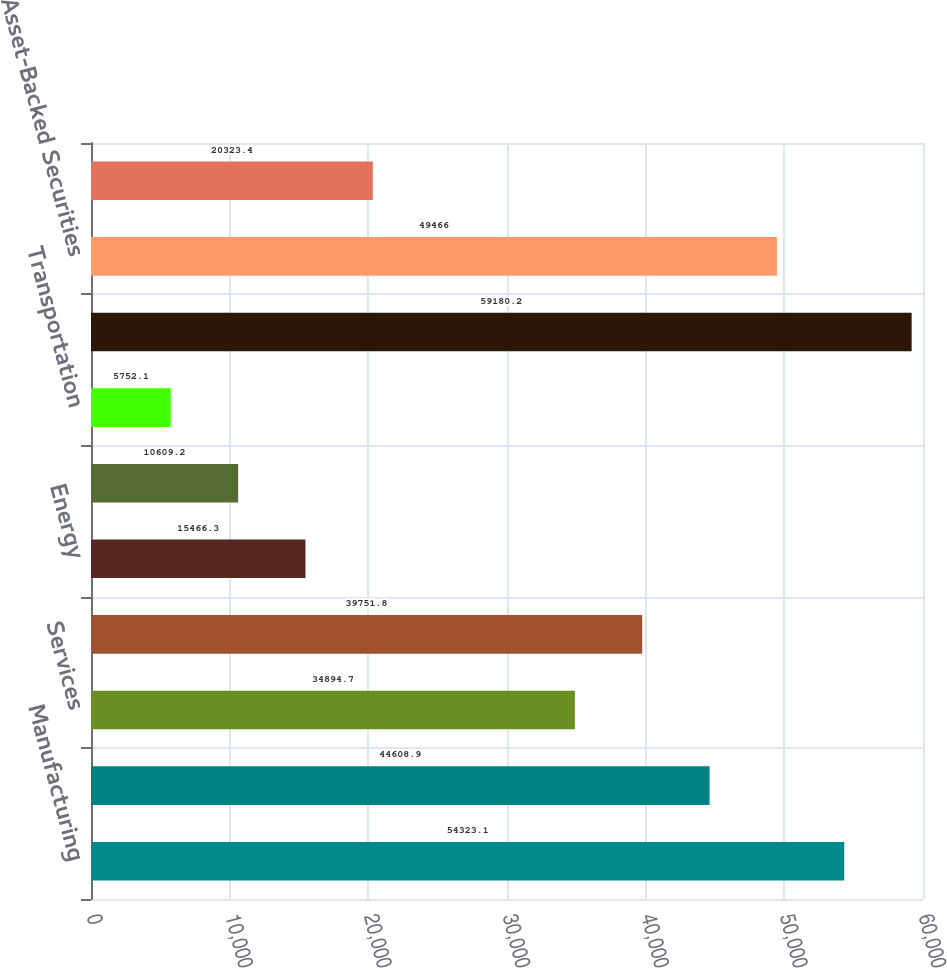<chart> <loc_0><loc_0><loc_500><loc_500><bar_chart><fcel>Manufacturing<fcel>Utilities<fcel>Services<fcel>Finance<fcel>Energy<fcel>Retail and Wholesale<fcel>Transportation<fcel>Total Corporate Securities<fcel>Asset-Backed Securities<fcel>Residential Mortgage Backed<nl><fcel>54323.1<fcel>44608.9<fcel>34894.7<fcel>39751.8<fcel>15466.3<fcel>10609.2<fcel>5752.1<fcel>59180.2<fcel>49466<fcel>20323.4<nl></chart> 